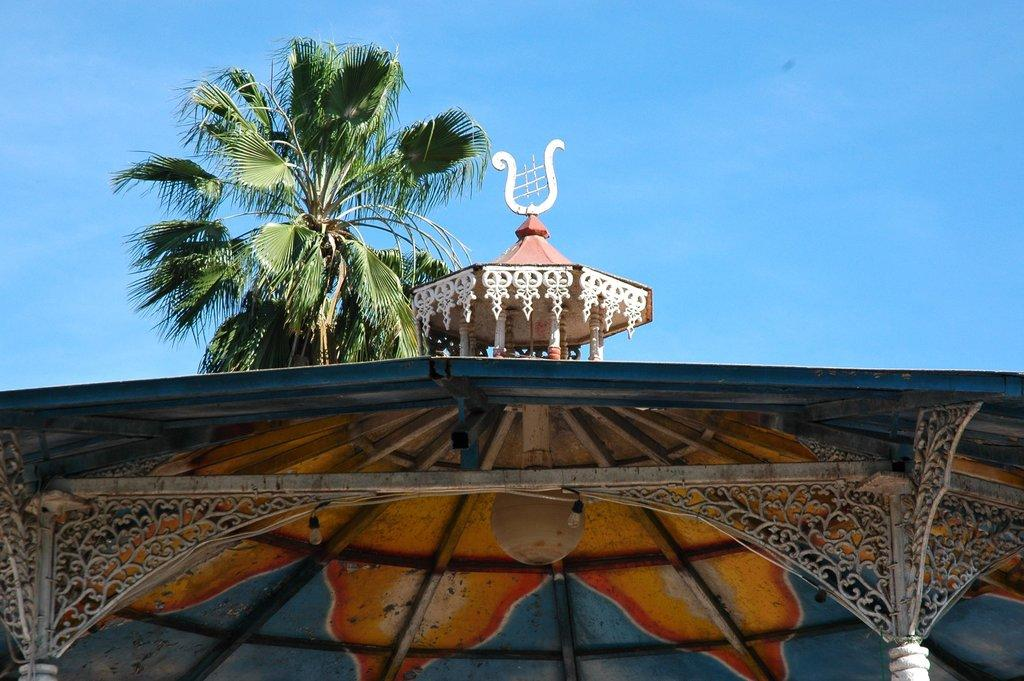What is located on the roof in the image? There are lights and poles on the roof in the image. What can be seen in the background of the image? There is a tree and the sky visible in the background of the image. Reasoning: Let's think step by step by step in order to produce the conversation. We start by identifying the main subjects and objects in the image based on the provided facts. We then formulate questions that focus on the location and characteristics of these subjects and objects, ensuring that each question can be answered definitively with the information given. We avoid yes/no/no questions and ensure that the language is simple and clear. Absurd Question/Answer: How many stems are visible on the tree in the image? There is no tree with stems visible in the image; only the lights, poles, and background elements are present. What color are the eyes of the person in the image? There is no person with eyes visible in the image. How many strings are attached to the lights on the roof in the image? There are no strings attached to the lights on the roof in the image; only the lights and poles are present. 